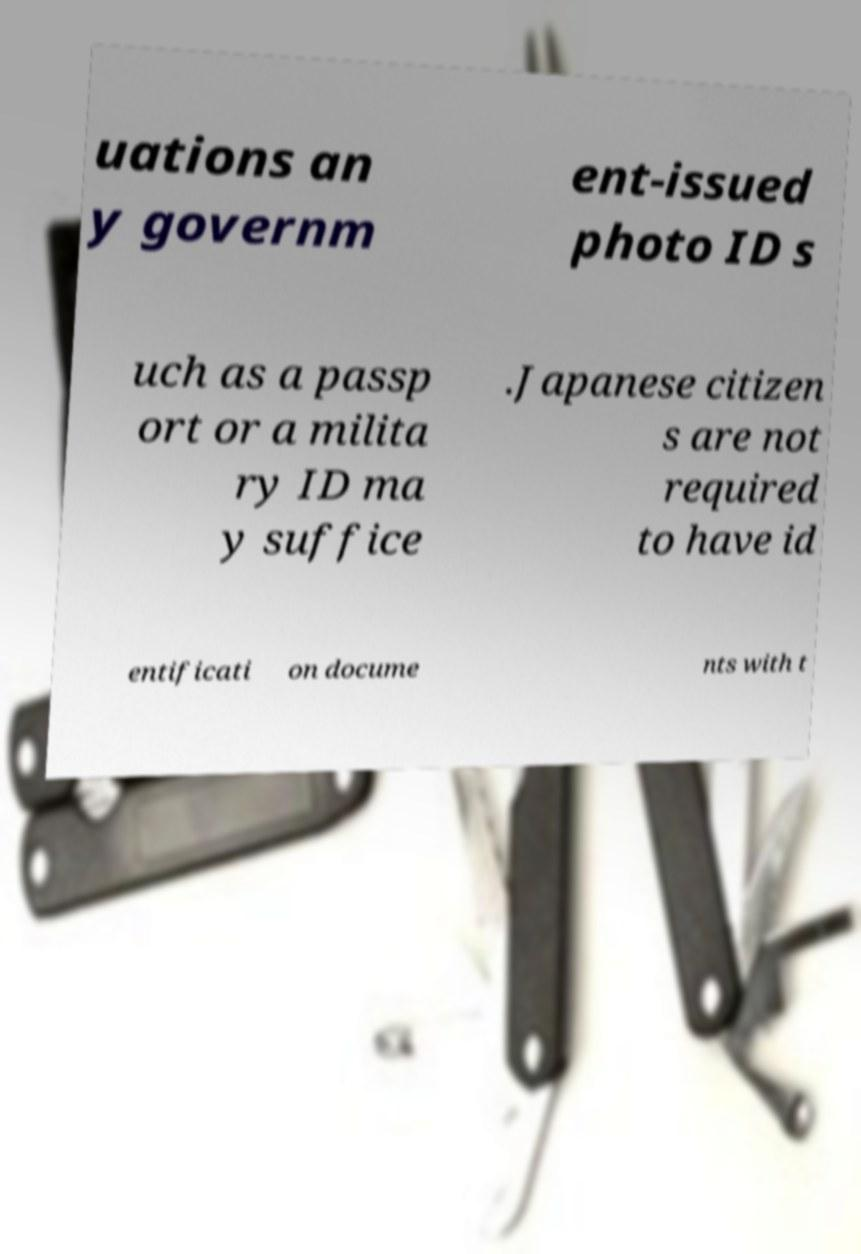For documentation purposes, I need the text within this image transcribed. Could you provide that? uations an y governm ent-issued photo ID s uch as a passp ort or a milita ry ID ma y suffice .Japanese citizen s are not required to have id entificati on docume nts with t 